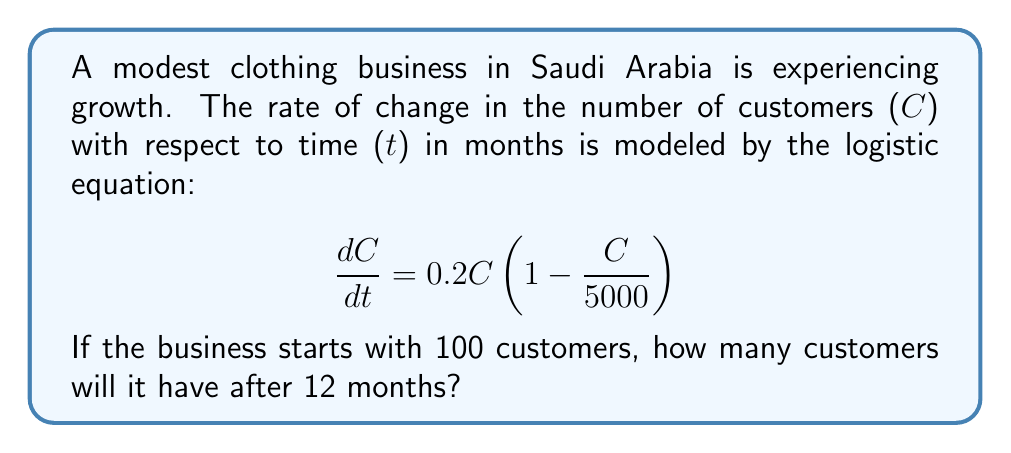Could you help me with this problem? To solve this problem, we need to use the logistic growth formula:

$$C(t) = \frac{K}{1 + (\frac{K}{C_0} - 1)e^{-rt}}$$

Where:
- $K$ is the carrying capacity (5000 in this case)
- $C_0$ is the initial number of customers (100)
- $r$ is the growth rate (0.2)
- $t$ is the time in months (12)

Let's substitute these values into the formula:

$$C(12) = \frac{5000}{1 + (\frac{5000}{100} - 1)e^{-0.2(12)}}$$

Simplify:
$$C(12) = \frac{5000}{1 + (50 - 1)e^{-2.4}}$$
$$C(12) = \frac{5000}{1 + 49e^{-2.4}}$$

Calculate $e^{-2.4}$:
$$e^{-2.4} \approx 0.0907$$

Substitute this value:
$$C(12) = \frac{5000}{1 + 49(0.0907)}$$
$$C(12) = \frac{5000}{1 + 4.4443}$$
$$C(12) = \frac{5000}{5.4443}$$

Calculate the final result:
$$C(12) \approx 918.56$$

Rounding to the nearest whole number:
$$C(12) \approx 919$$
Answer: 919 customers 